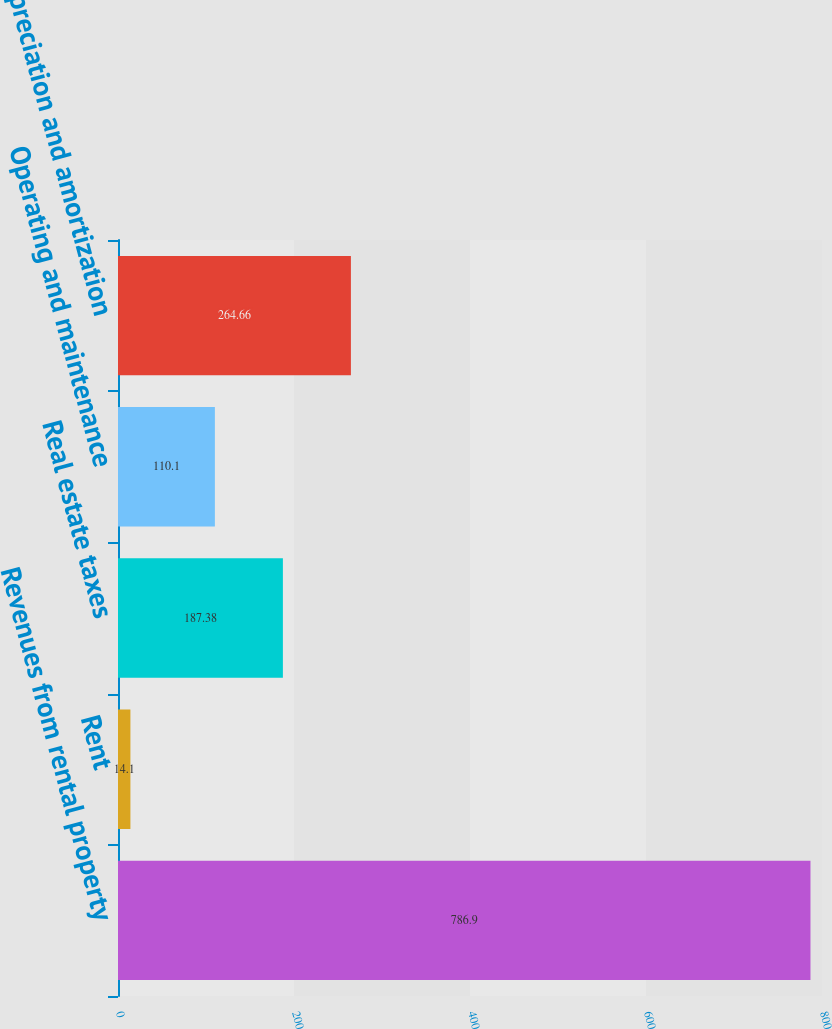Convert chart to OTSL. <chart><loc_0><loc_0><loc_500><loc_500><bar_chart><fcel>Revenues from rental property<fcel>Rent<fcel>Real estate taxes<fcel>Operating and maintenance<fcel>Depreciation and amortization<nl><fcel>786.9<fcel>14.1<fcel>187.38<fcel>110.1<fcel>264.66<nl></chart> 